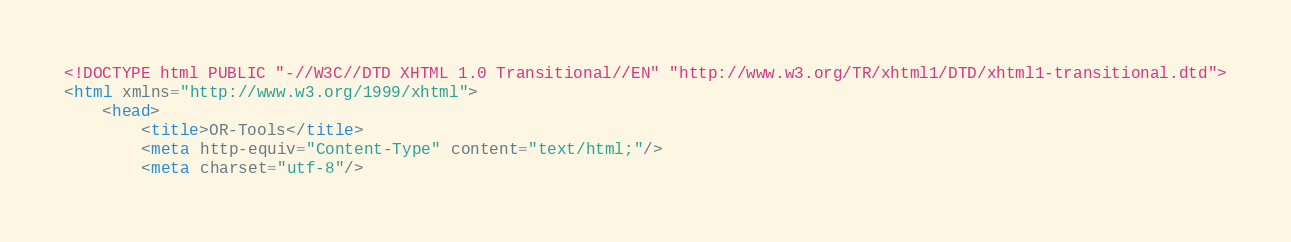<code> <loc_0><loc_0><loc_500><loc_500><_HTML_><!DOCTYPE html PUBLIC "-//W3C//DTD XHTML 1.0 Transitional//EN" "http://www.w3.org/TR/xhtml1/DTD/xhtml1-transitional.dtd">
<html xmlns="http://www.w3.org/1999/xhtml">
    <head>
        <title>OR-Tools</title>
        <meta http-equiv="Content-Type" content="text/html;"/>
        <meta charset="utf-8"/></code> 